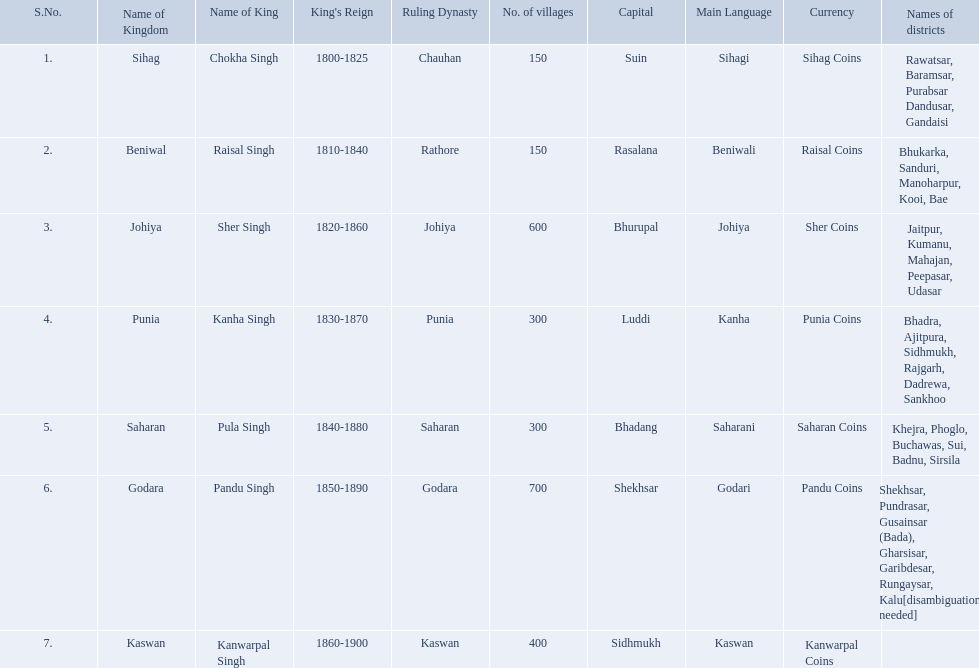Which kingdom contained the least amount of villages along with sihag? Beniwal. Which kingdom contained the most villages? Godara. Which village was tied at second most villages with godara? Johiya. 